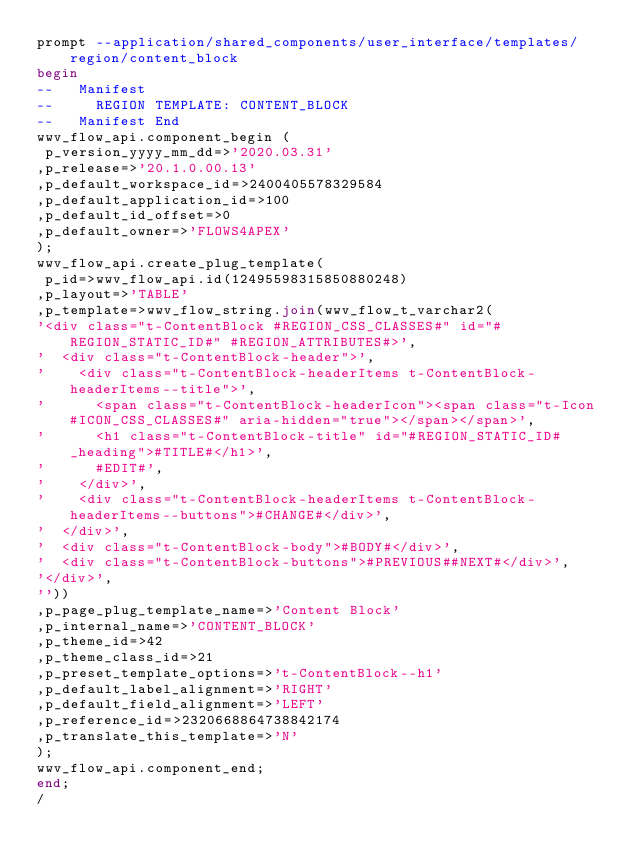<code> <loc_0><loc_0><loc_500><loc_500><_SQL_>prompt --application/shared_components/user_interface/templates/region/content_block
begin
--   Manifest
--     REGION TEMPLATE: CONTENT_BLOCK
--   Manifest End
wwv_flow_api.component_begin (
 p_version_yyyy_mm_dd=>'2020.03.31'
,p_release=>'20.1.0.00.13'
,p_default_workspace_id=>2400405578329584
,p_default_application_id=>100
,p_default_id_offset=>0
,p_default_owner=>'FLOWS4APEX'
);
wwv_flow_api.create_plug_template(
 p_id=>wwv_flow_api.id(12495598315850880248)
,p_layout=>'TABLE'
,p_template=>wwv_flow_string.join(wwv_flow_t_varchar2(
'<div class="t-ContentBlock #REGION_CSS_CLASSES#" id="#REGION_STATIC_ID#" #REGION_ATTRIBUTES#>',
'  <div class="t-ContentBlock-header">',
'    <div class="t-ContentBlock-headerItems t-ContentBlock-headerItems--title">',
'      <span class="t-ContentBlock-headerIcon"><span class="t-Icon #ICON_CSS_CLASSES#" aria-hidden="true"></span></span>',
'      <h1 class="t-ContentBlock-title" id="#REGION_STATIC_ID#_heading">#TITLE#</h1>',
'      #EDIT#',
'    </div>',
'    <div class="t-ContentBlock-headerItems t-ContentBlock-headerItems--buttons">#CHANGE#</div>',
'  </div>',
'  <div class="t-ContentBlock-body">#BODY#</div>',
'  <div class="t-ContentBlock-buttons">#PREVIOUS##NEXT#</div>',
'</div>',
''))
,p_page_plug_template_name=>'Content Block'
,p_internal_name=>'CONTENT_BLOCK'
,p_theme_id=>42
,p_theme_class_id=>21
,p_preset_template_options=>'t-ContentBlock--h1'
,p_default_label_alignment=>'RIGHT'
,p_default_field_alignment=>'LEFT'
,p_reference_id=>2320668864738842174
,p_translate_this_template=>'N'
);
wwv_flow_api.component_end;
end;
/
</code> 